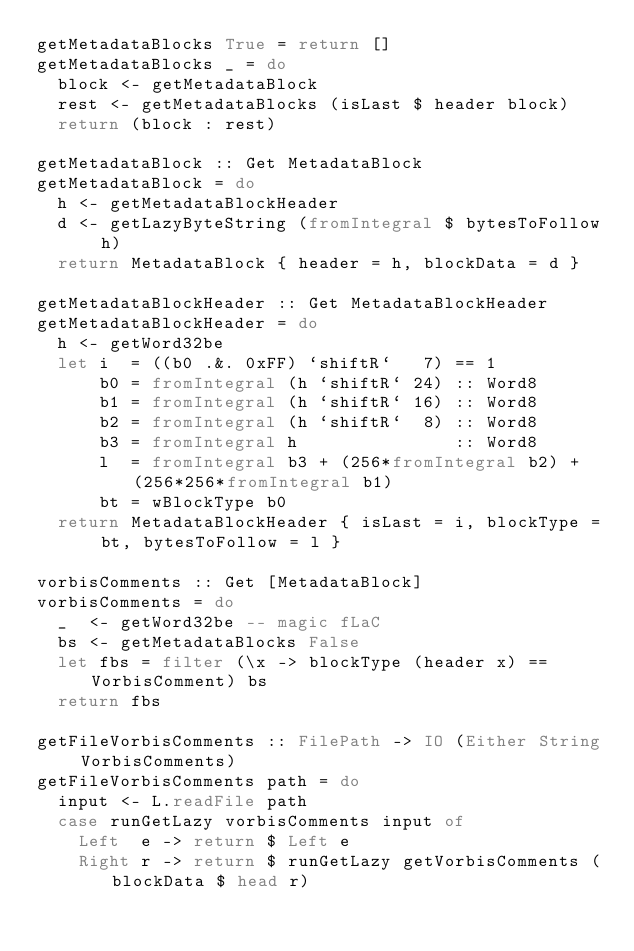Convert code to text. <code><loc_0><loc_0><loc_500><loc_500><_Haskell_>getMetadataBlocks True = return []
getMetadataBlocks _ = do
  block <- getMetadataBlock
  rest <- getMetadataBlocks (isLast $ header block)
  return (block : rest)

getMetadataBlock :: Get MetadataBlock
getMetadataBlock = do
  h <- getMetadataBlockHeader
  d <- getLazyByteString (fromIntegral $ bytesToFollow h)
  return MetadataBlock { header = h, blockData = d }

getMetadataBlockHeader :: Get MetadataBlockHeader
getMetadataBlockHeader = do
  h <- getWord32be
  let i  = ((b0 .&. 0xFF) `shiftR`   7) == 1
      b0 = fromIntegral (h `shiftR` 24) :: Word8
      b1 = fromIntegral (h `shiftR` 16) :: Word8
      b2 = fromIntegral (h `shiftR`  8) :: Word8
      b3 = fromIntegral h               :: Word8
      l  = fromIntegral b3 + (256*fromIntegral b2) + (256*256*fromIntegral b1)
      bt = wBlockType b0
  return MetadataBlockHeader { isLast = i, blockType = bt, bytesToFollow = l }

vorbisComments :: Get [MetadataBlock]
vorbisComments = do
  _  <- getWord32be -- magic fLaC
  bs <- getMetadataBlocks False
  let fbs = filter (\x -> blockType (header x) == VorbisComment) bs
  return fbs

getFileVorbisComments :: FilePath -> IO (Either String VorbisComments)
getFileVorbisComments path = do
  input <- L.readFile path
  case runGetLazy vorbisComments input of
    Left  e -> return $ Left e
    Right r -> return $ runGetLazy getVorbisComments (blockData $ head r)
</code> 